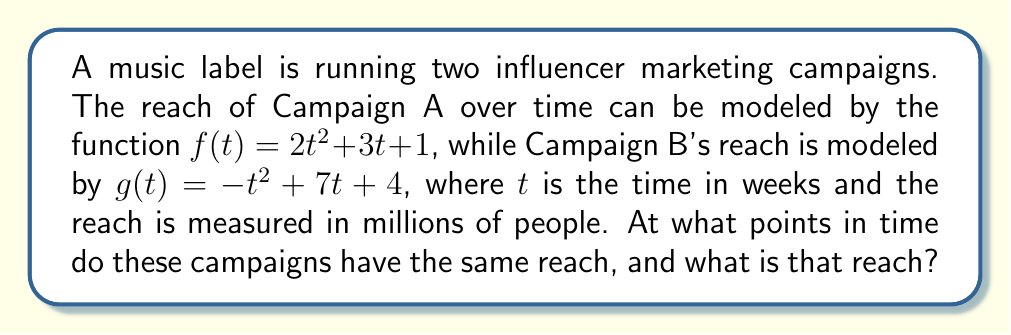Can you answer this question? To find the intersection points of the two campaign trajectories, we need to solve the equation $f(t) = g(t)$:

1) Set up the equation:
   $2t^2 + 3t + 1 = -t^2 + 7t + 4$

2) Rearrange to standard form:
   $2t^2 + 3t + 1 + t^2 - 7t - 4 = 0$
   $3t^2 - 4t - 3 = 0$

3) This is a quadratic equation in the form $at^2 + bt + c = 0$, where:
   $a = 3$, $b = -4$, and $c = -3$

4) Use the quadratic formula: $t = \frac{-b \pm \sqrt{b^2 - 4ac}}{2a}$

5) Substitute the values:
   $t = \frac{4 \pm \sqrt{(-4)^2 - 4(3)(-3)}}{2(3)}$
   $t = \frac{4 \pm \sqrt{16 + 36}}{6}$
   $t = \frac{4 \pm \sqrt{52}}{6}$
   $t = \frac{4 \pm 2\sqrt{13}}{6}$

6) Simplify:
   $t_1 = \frac{2 + \sqrt{13}}{3}$ and $t_2 = \frac{2 - \sqrt{13}}{3}$

7) To find the reach at these points, substitute either $t_1$ or $t_2$ into $f(t)$ or $g(t)$:
   Using $f(t)$ and $t_1$:
   $f(t_1) = 2(\frac{2 + \sqrt{13}}{3})^2 + 3(\frac{2 + \sqrt{13}}{3}) + 1$
   
   Simplifying this expression yields: $\frac{49 + 13\sqrt{13}}{9}$

Therefore, the campaigns intersect at $t = \frac{2 + \sqrt{13}}{3}$ and $t = \frac{2 - \sqrt{13}}{3}$ weeks, with a reach of $\frac{49 + 13\sqrt{13}}{9}$ million people.
Answer: $t = \frac{2 \pm \sqrt{13}}{3}$ weeks; Reach = $\frac{49 + 13\sqrt{13}}{9}$ million 